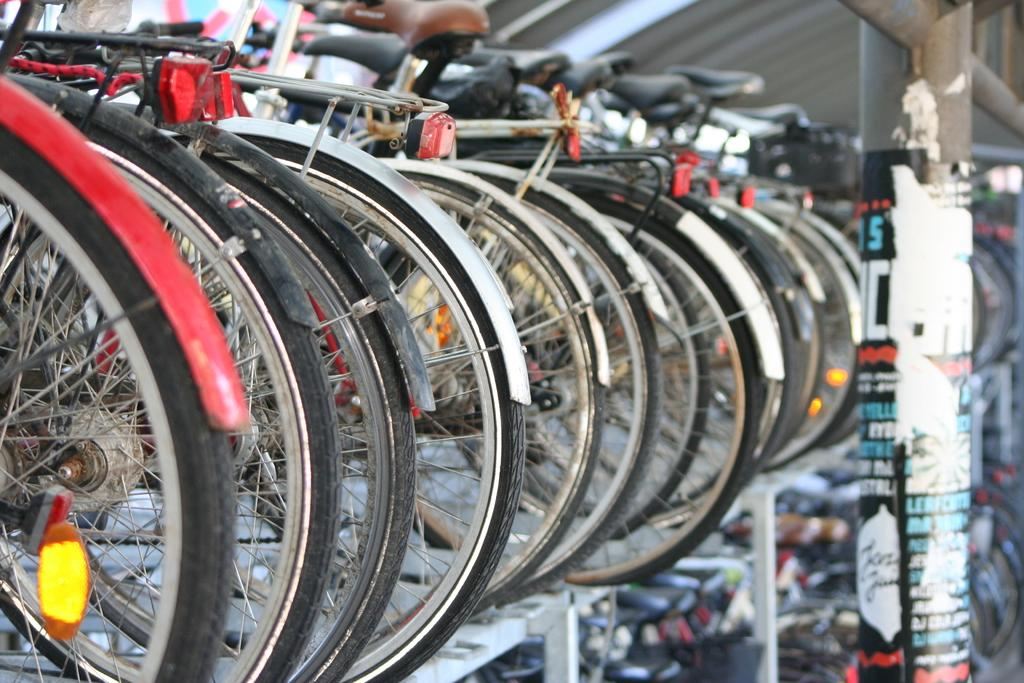What structure is present in the image for bicycles? There is a bicycle stand in the image. How many bicycles are at the stand in the image? There are many bicycles at the stand in the image. What other object can be seen in the image? There is a pole in the image. What type of blade is being used to temper the hand in the image? There is no blade, hand, or tempering activity present in the image. 